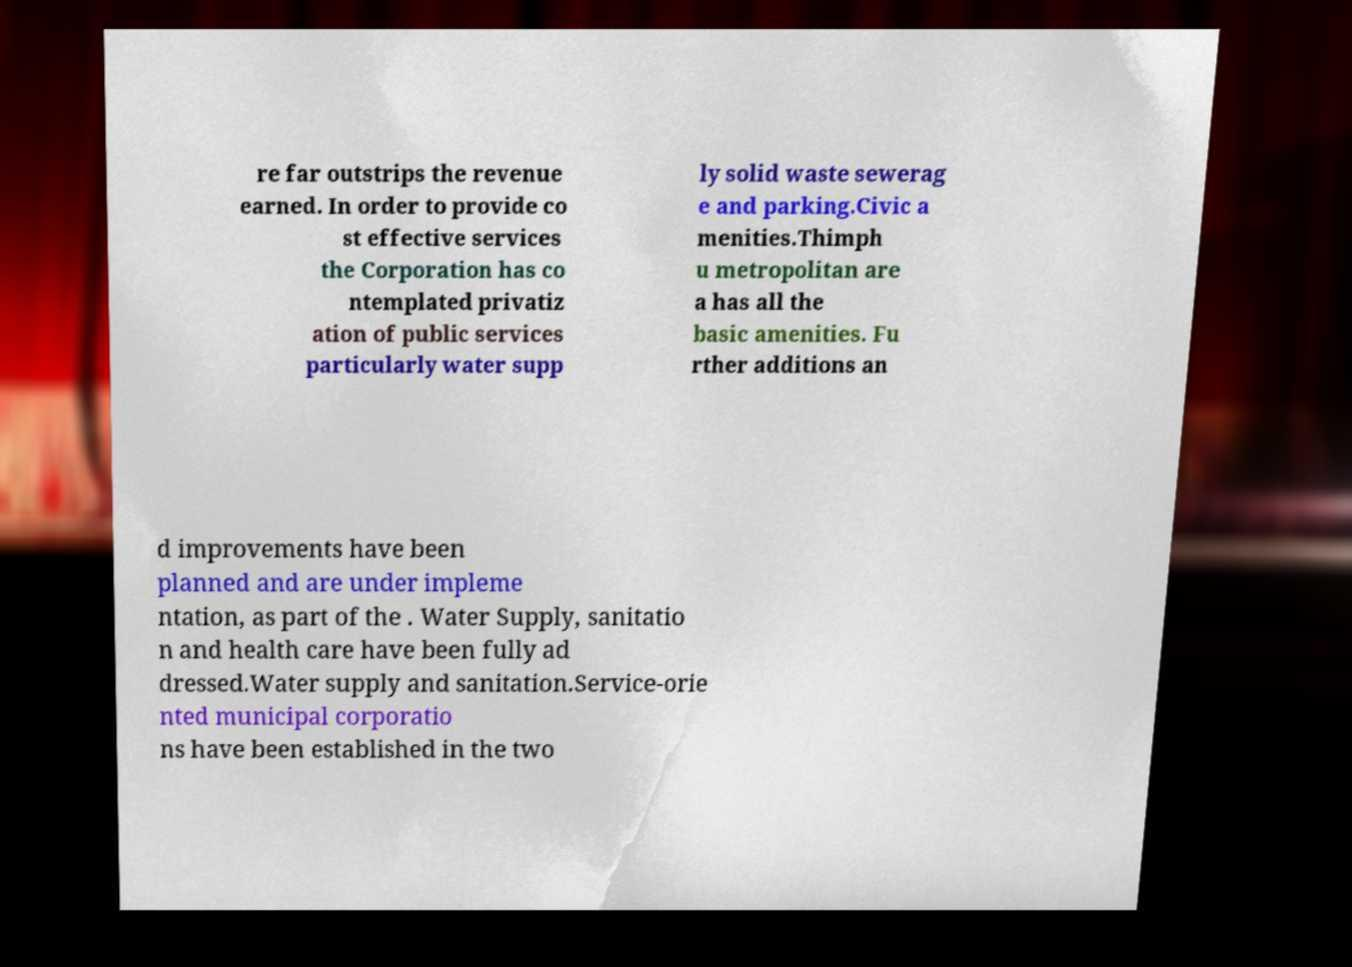What messages or text are displayed in this image? I need them in a readable, typed format. re far outstrips the revenue earned. In order to provide co st effective services the Corporation has co ntemplated privatiz ation of public services particularly water supp ly solid waste sewerag e and parking.Civic a menities.Thimph u metropolitan are a has all the basic amenities. Fu rther additions an d improvements have been planned and are under impleme ntation, as part of the . Water Supply, sanitatio n and health care have been fully ad dressed.Water supply and sanitation.Service-orie nted municipal corporatio ns have been established in the two 